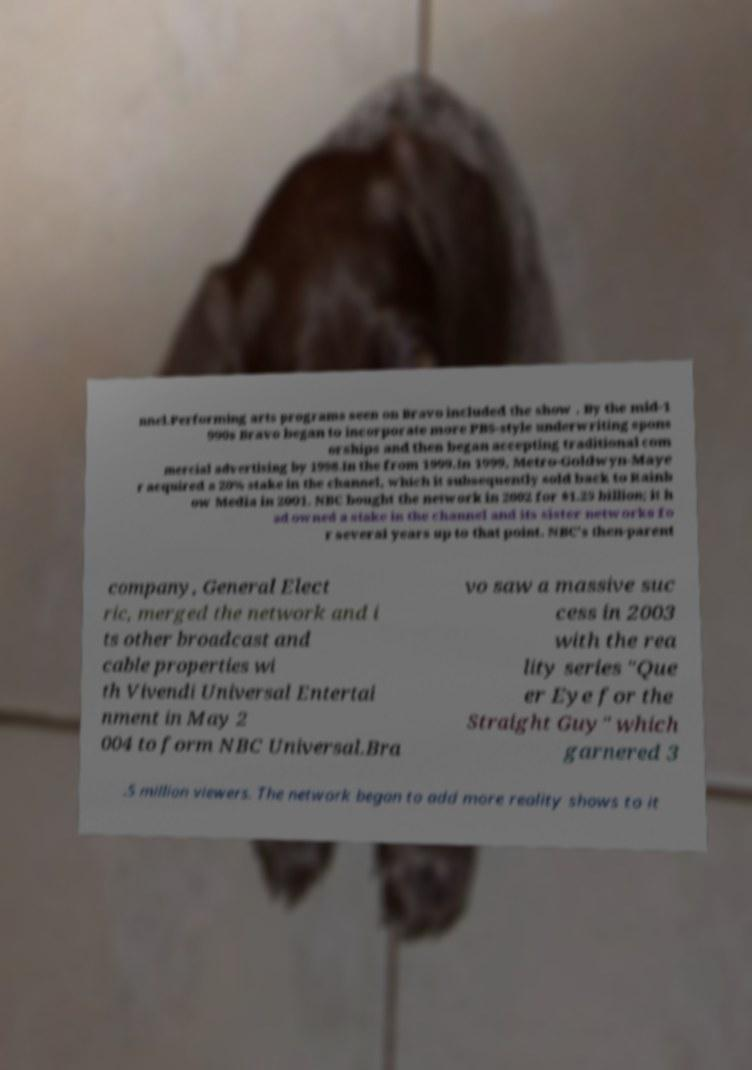Can you accurately transcribe the text from the provided image for me? nnel.Performing arts programs seen on Bravo included the show . By the mid-1 990s Bravo began to incorporate more PBS-style underwriting spons orships and then began accepting traditional com mercial advertising by 1998.In the from 1999.In 1999, Metro-Goldwyn-Maye r acquired a 20% stake in the channel, which it subsequently sold back to Rainb ow Media in 2001. NBC bought the network in 2002 for $1.25 billion; it h ad owned a stake in the channel and its sister networks fo r several years up to that point. NBC's then-parent company, General Elect ric, merged the network and i ts other broadcast and cable properties wi th Vivendi Universal Entertai nment in May 2 004 to form NBC Universal.Bra vo saw a massive suc cess in 2003 with the rea lity series "Que er Eye for the Straight Guy" which garnered 3 .5 million viewers. The network began to add more reality shows to it 